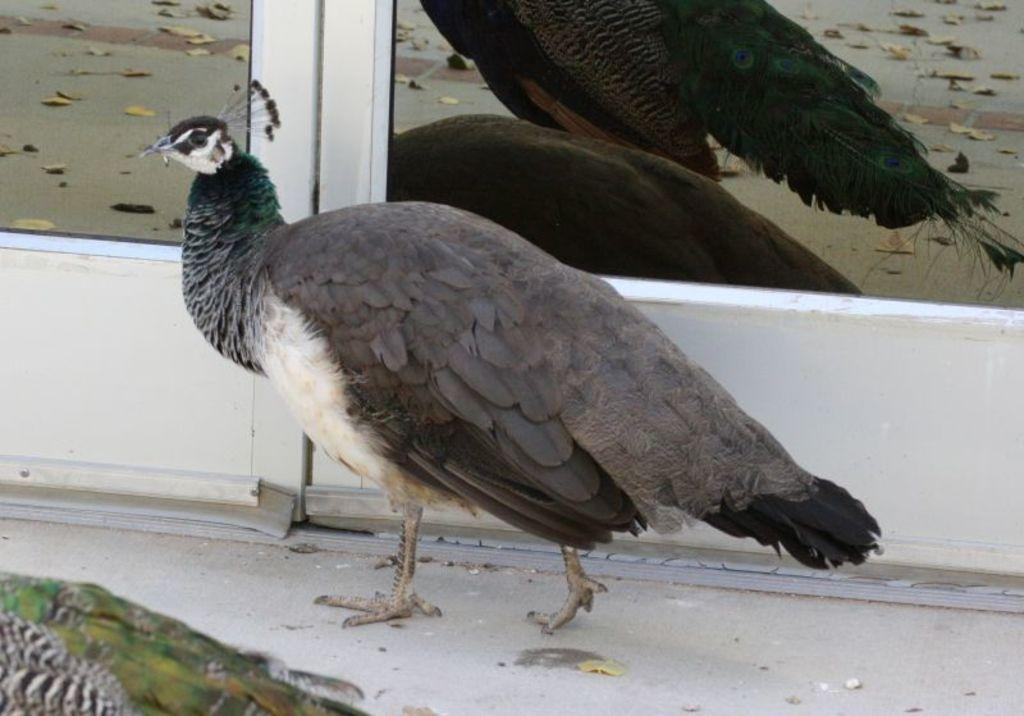What type of animal is present in the image? There is a peacock in the image. Are there any other peacocks in the image? Yes, there is another peacock beside the first one. What can be seen in the background of the image? There is a glass door in the background of the image. What type of whip is being used by the peacock in the image? There is no whip present in the image; it features two peacocks and a glass door in the background. 